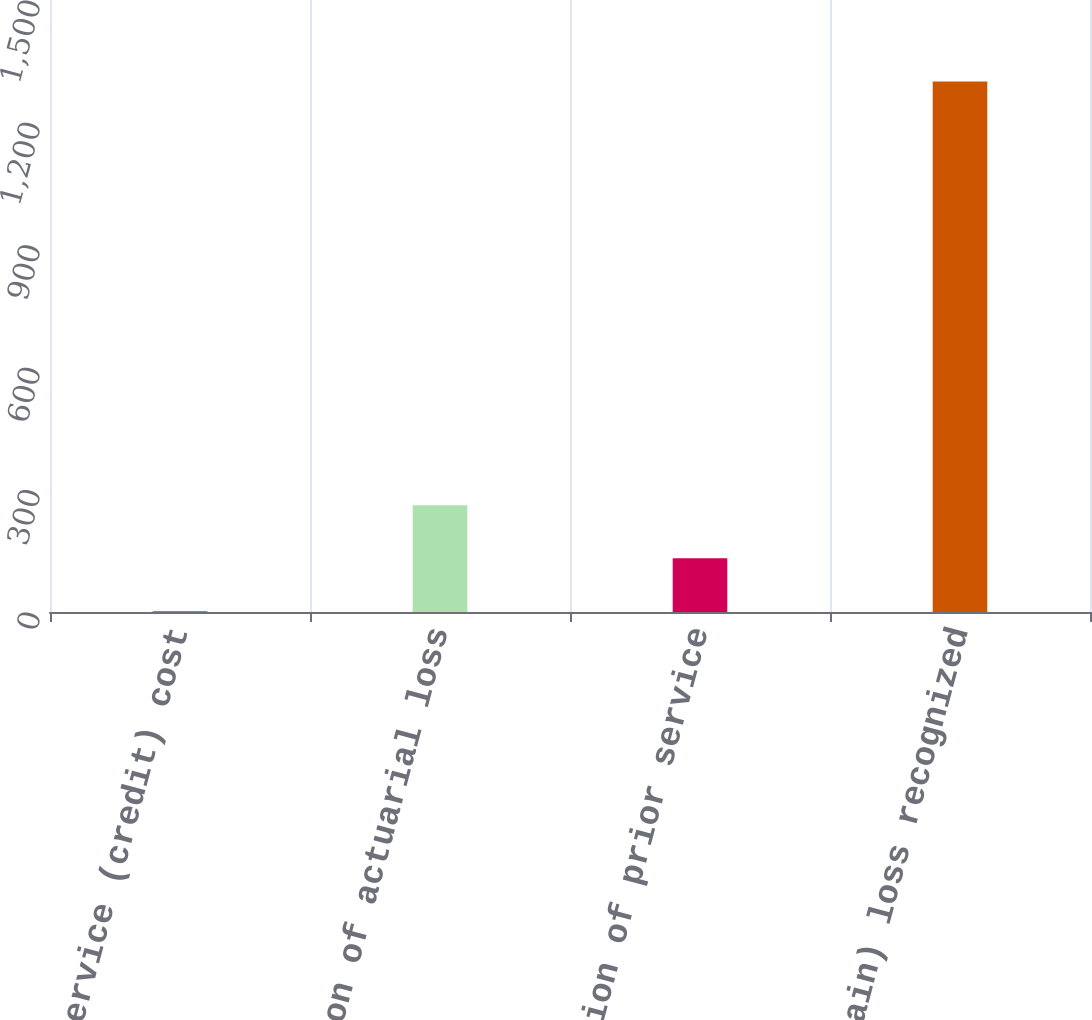Convert chart. <chart><loc_0><loc_0><loc_500><loc_500><bar_chart><fcel>Prior service (credit) cost<fcel>Amortization of actuarial loss<fcel>Amortization of prior service<fcel>Total (gain) loss recognized<nl><fcel>2<fcel>261.6<fcel>131.8<fcel>1300<nl></chart> 